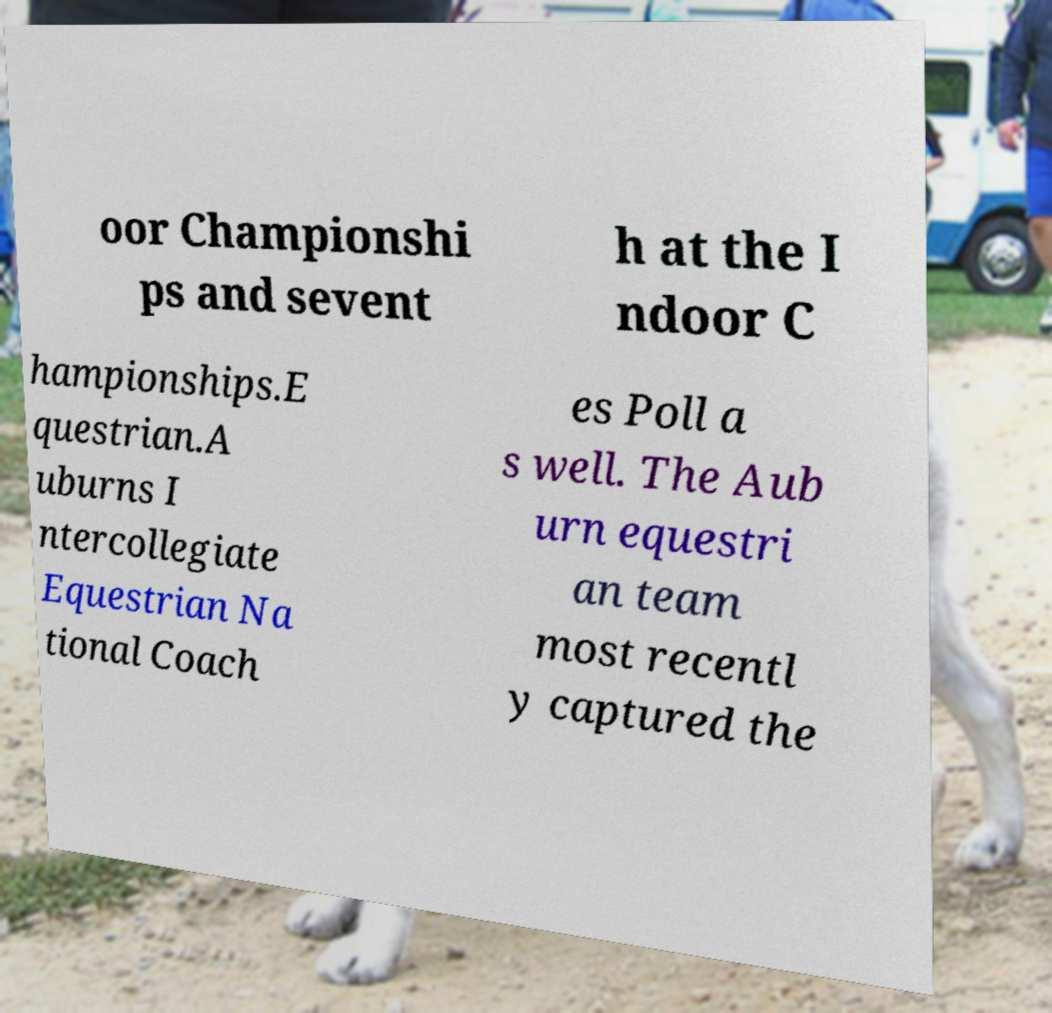Can you read and provide the text displayed in the image?This photo seems to have some interesting text. Can you extract and type it out for me? oor Championshi ps and sevent h at the I ndoor C hampionships.E questrian.A uburns I ntercollegiate Equestrian Na tional Coach es Poll a s well. The Aub urn equestri an team most recentl y captured the 